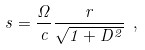Convert formula to latex. <formula><loc_0><loc_0><loc_500><loc_500>s = \frac { \Omega } { c } \frac { r } { \sqrt { 1 + D ^ { 2 } } } \ ,</formula> 